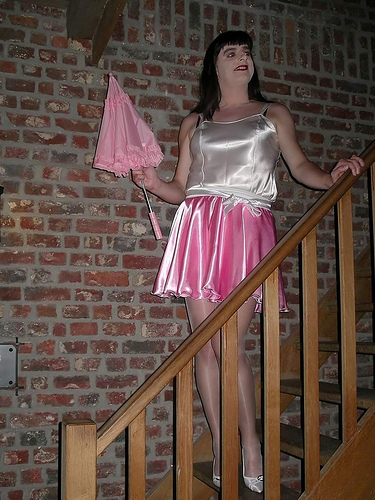<image>
Is there a woman under the umbrella? No. The woman is not positioned under the umbrella. The vertical relationship between these objects is different. Where is the umbrella in relation to the bricks? Is it to the right of the bricks? No. The umbrella is not to the right of the bricks. The horizontal positioning shows a different relationship. Is the umbrella above the wall? No. The umbrella is not positioned above the wall. The vertical arrangement shows a different relationship. 